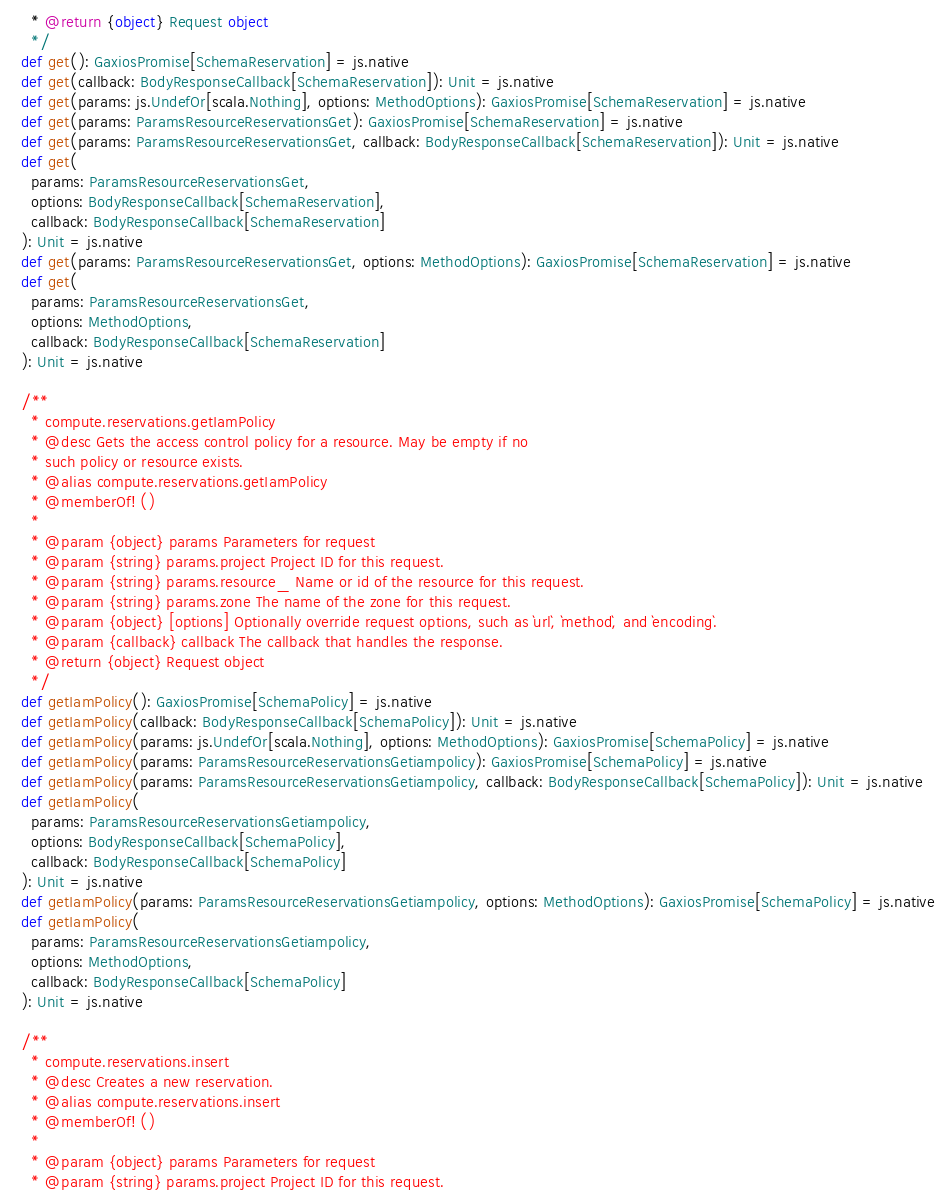Convert code to text. <code><loc_0><loc_0><loc_500><loc_500><_Scala_>    * @return {object} Request object
    */
  def get(): GaxiosPromise[SchemaReservation] = js.native
  def get(callback: BodyResponseCallback[SchemaReservation]): Unit = js.native
  def get(params: js.UndefOr[scala.Nothing], options: MethodOptions): GaxiosPromise[SchemaReservation] = js.native
  def get(params: ParamsResourceReservationsGet): GaxiosPromise[SchemaReservation] = js.native
  def get(params: ParamsResourceReservationsGet, callback: BodyResponseCallback[SchemaReservation]): Unit = js.native
  def get(
    params: ParamsResourceReservationsGet,
    options: BodyResponseCallback[SchemaReservation],
    callback: BodyResponseCallback[SchemaReservation]
  ): Unit = js.native
  def get(params: ParamsResourceReservationsGet, options: MethodOptions): GaxiosPromise[SchemaReservation] = js.native
  def get(
    params: ParamsResourceReservationsGet,
    options: MethodOptions,
    callback: BodyResponseCallback[SchemaReservation]
  ): Unit = js.native
  
  /**
    * compute.reservations.getIamPolicy
    * @desc Gets the access control policy for a resource. May be empty if no
    * such policy or resource exists.
    * @alias compute.reservations.getIamPolicy
    * @memberOf! ()
    *
    * @param {object} params Parameters for request
    * @param {string} params.project Project ID for this request.
    * @param {string} params.resource_ Name or id of the resource for this request.
    * @param {string} params.zone The name of the zone for this request.
    * @param {object} [options] Optionally override request options, such as `url`, `method`, and `encoding`.
    * @param {callback} callback The callback that handles the response.
    * @return {object} Request object
    */
  def getIamPolicy(): GaxiosPromise[SchemaPolicy] = js.native
  def getIamPolicy(callback: BodyResponseCallback[SchemaPolicy]): Unit = js.native
  def getIamPolicy(params: js.UndefOr[scala.Nothing], options: MethodOptions): GaxiosPromise[SchemaPolicy] = js.native
  def getIamPolicy(params: ParamsResourceReservationsGetiampolicy): GaxiosPromise[SchemaPolicy] = js.native
  def getIamPolicy(params: ParamsResourceReservationsGetiampolicy, callback: BodyResponseCallback[SchemaPolicy]): Unit = js.native
  def getIamPolicy(
    params: ParamsResourceReservationsGetiampolicy,
    options: BodyResponseCallback[SchemaPolicy],
    callback: BodyResponseCallback[SchemaPolicy]
  ): Unit = js.native
  def getIamPolicy(params: ParamsResourceReservationsGetiampolicy, options: MethodOptions): GaxiosPromise[SchemaPolicy] = js.native
  def getIamPolicy(
    params: ParamsResourceReservationsGetiampolicy,
    options: MethodOptions,
    callback: BodyResponseCallback[SchemaPolicy]
  ): Unit = js.native
  
  /**
    * compute.reservations.insert
    * @desc Creates a new reservation.
    * @alias compute.reservations.insert
    * @memberOf! ()
    *
    * @param {object} params Parameters for request
    * @param {string} params.project Project ID for this request.</code> 